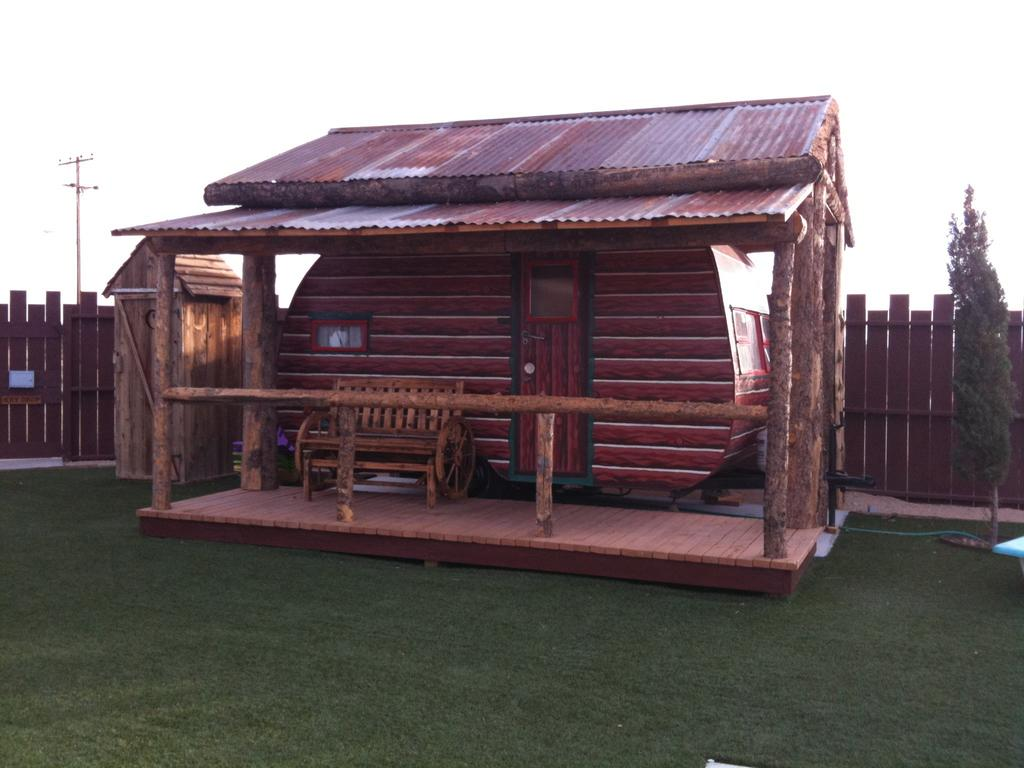What type of structure is in the middle of the image? There is a wooden house in the middle of the image. What can be found inside the wooden house? Inside the wooden house, there is a bench and a door. What is located on the left side of the image? There is a small wooden house on the left side of the image. What can be seen in the background of the image? In the background, there is a fence, a plant, a pole, and the sky. How many cows are grazing in front of the wooden house in the image? There are no cows present in the image. What type of flower is growing near the plant in the background? There is no flower mentioned or visible in the image. 